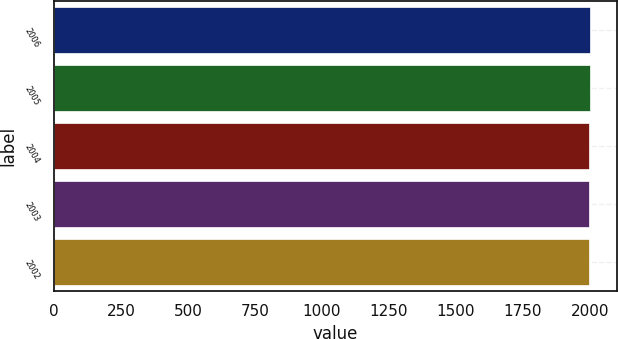Convert chart. <chart><loc_0><loc_0><loc_500><loc_500><bar_chart><fcel>2006<fcel>2005<fcel>2004<fcel>2003<fcel>2002<nl><fcel>2001<fcel>2000<fcel>1999<fcel>1998<fcel>1997<nl></chart> 